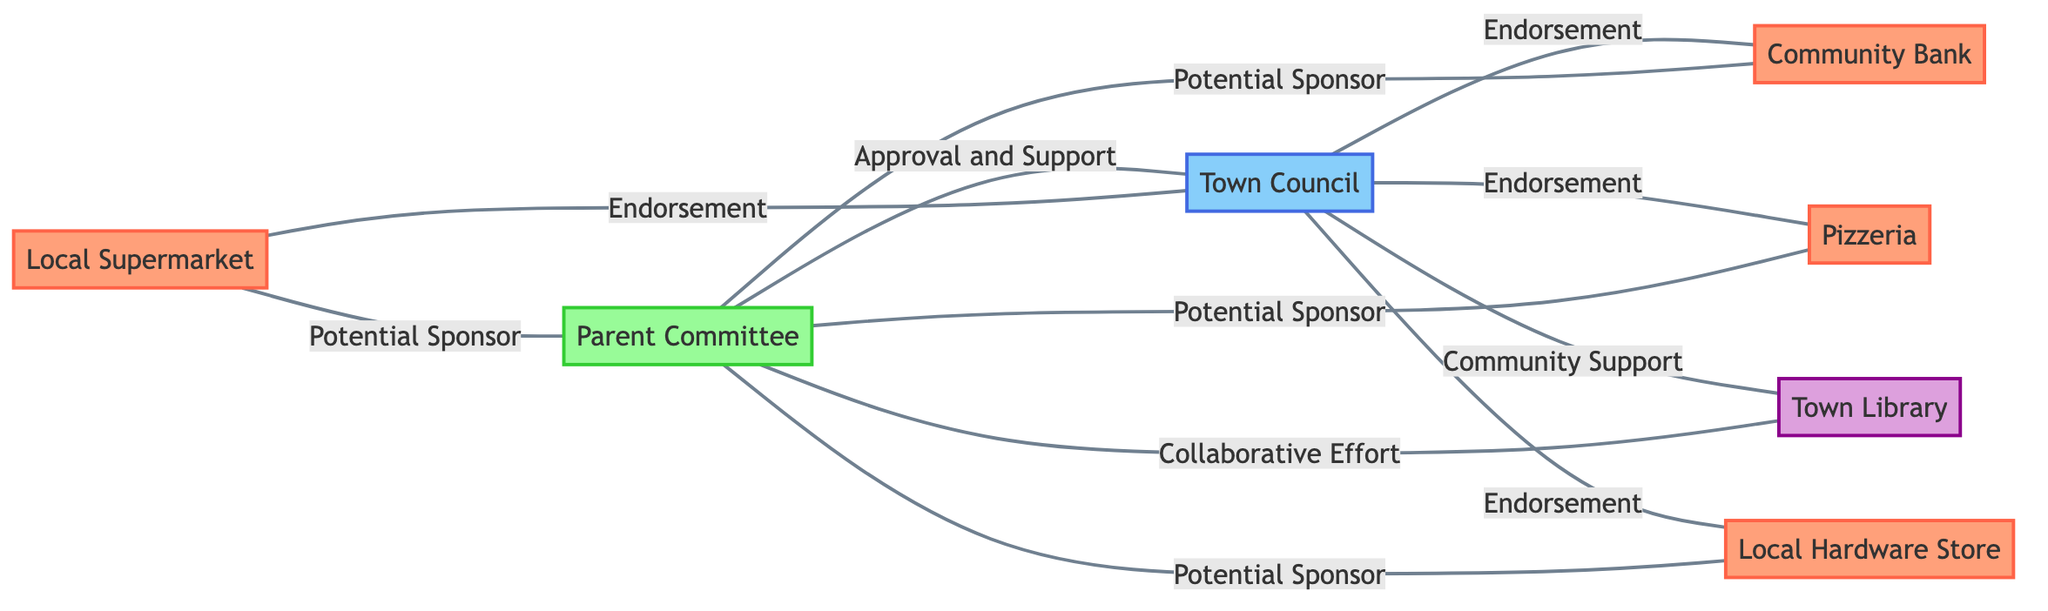What businesses are potential sponsors for the Little League program? The nodes connected to the "Parent Committee" with the label "Potential Sponsor" are the Local Supermarket, Community Bank, Pizzeria, and Local Hardware Store. These indicate the businesses that have expressed willingness to sponsor the program.
Answer: Local Supermarket, Community Bank, Pizzeria, Local Hardware Store Which business has a collaborative effort with the Parent Committee? The node "Town Library" has an edge labeled "Collaborative Effort" connecting it to the "Parent Committee". This signifies that the Town Library is not only a potential sponsor but is actively collaborating with the Parent Committee.
Answer: Town Library How many nodes are in the graph? By counting each unique node listed in the data, we identify seven distinct nodes representing local businesses and community organizations that participate in the potential sponsorship of the Little League program.
Answer: 7 What is the relationship between the Town Council and Local Supermarket? The edge labeled "Endorsement" connects the Town Council to the Local Supermarket. This indicates supportive action from the Town Council towards the Local Supermarket regarding the sponsorship.
Answer: Endorsement Which organization requires approval from the Town Council? The "Parent Committee" has an edge labeled "Approval and Support" connecting it to the "Town Council". This indicates that the Parent Committee needs the Town Council's approval to move forward with its initiatives.
Answer: Parent Committee 